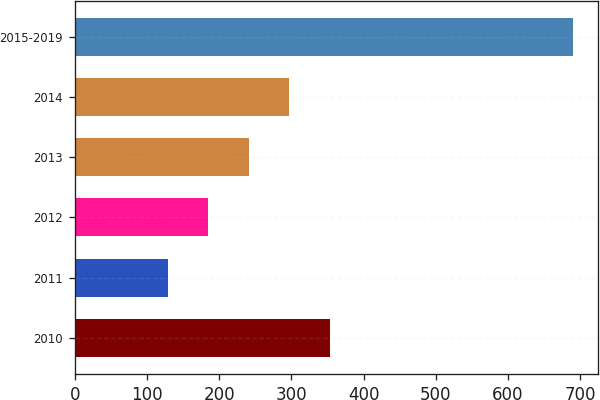<chart> <loc_0><loc_0><loc_500><loc_500><bar_chart><fcel>2010<fcel>2011<fcel>2012<fcel>2013<fcel>2014<fcel>2015-2019<nl><fcel>353.14<fcel>128.7<fcel>184.81<fcel>240.92<fcel>297.03<fcel>689.8<nl></chart> 